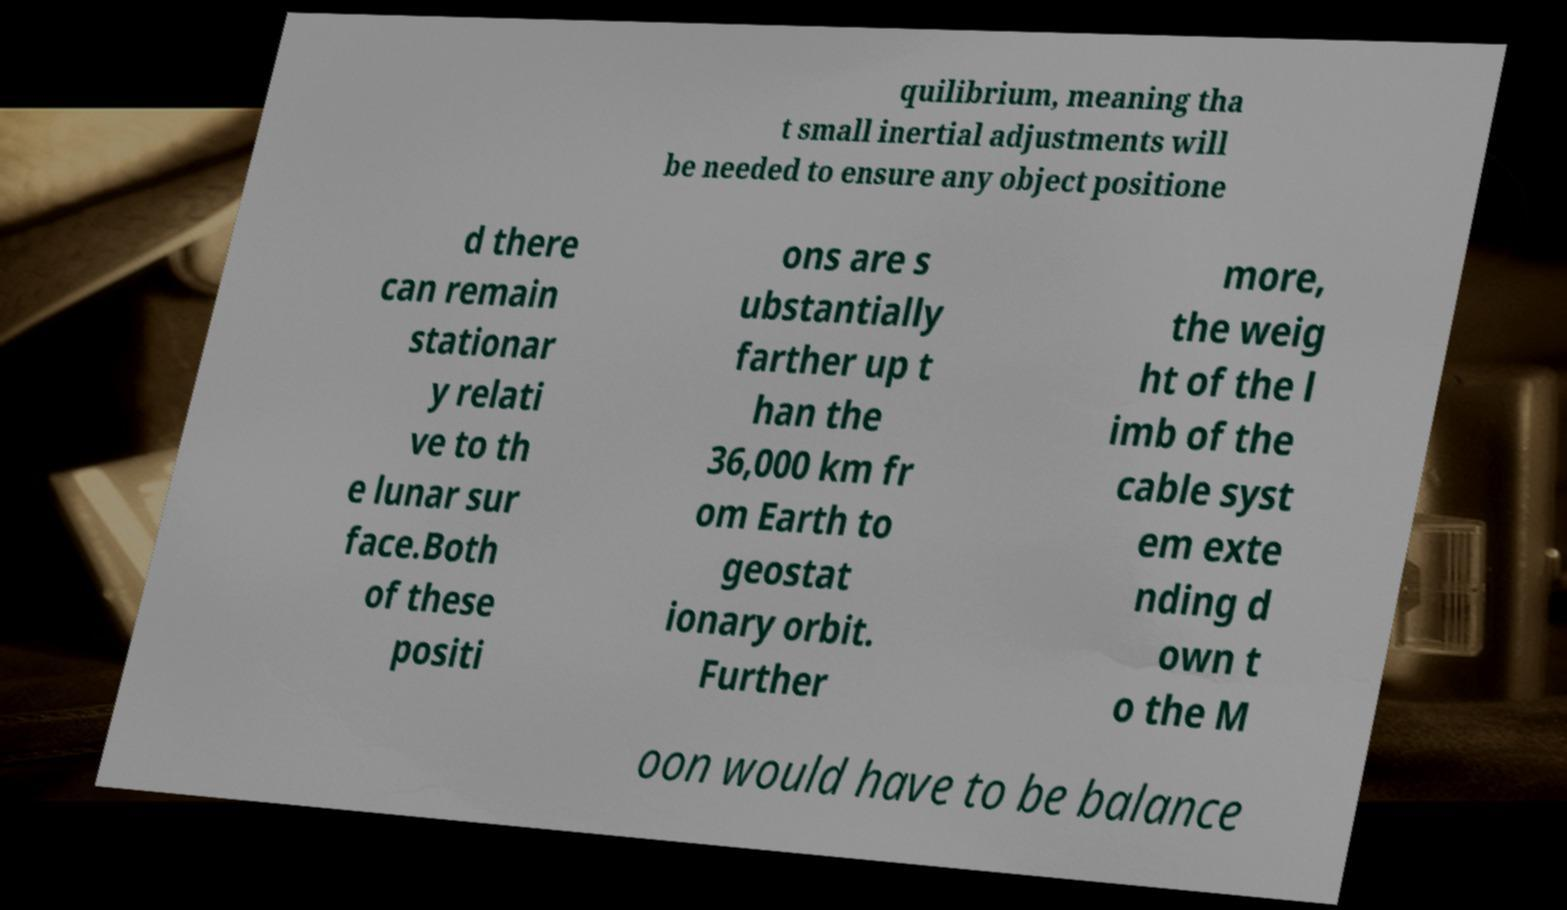Could you assist in decoding the text presented in this image and type it out clearly? quilibrium, meaning tha t small inertial adjustments will be needed to ensure any object positione d there can remain stationar y relati ve to th e lunar sur face.Both of these positi ons are s ubstantially farther up t han the 36,000 km fr om Earth to geostat ionary orbit. Further more, the weig ht of the l imb of the cable syst em exte nding d own t o the M oon would have to be balance 